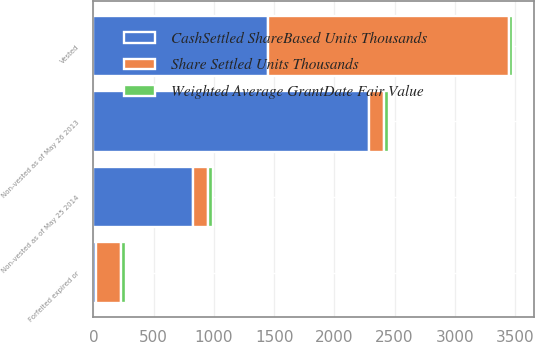Convert chart to OTSL. <chart><loc_0><loc_0><loc_500><loc_500><stacked_bar_chart><ecel><fcel>Non-vested as of May 26 2013<fcel>Vested<fcel>Forfeited expired or<fcel>Non-vested as of May 25 2014<nl><fcel>Share Settled Units Thousands<fcel>127.165<fcel>2004.8<fcel>213.5<fcel>127.165<nl><fcel>Weighted Average GrantDate Fair Value<fcel>35.89<fcel>29.76<fcel>40.83<fcel>40.81<nl><fcel>CashSettled ShareBased Units Thousands<fcel>2287.8<fcel>1445.5<fcel>19.5<fcel>822.8<nl></chart> 